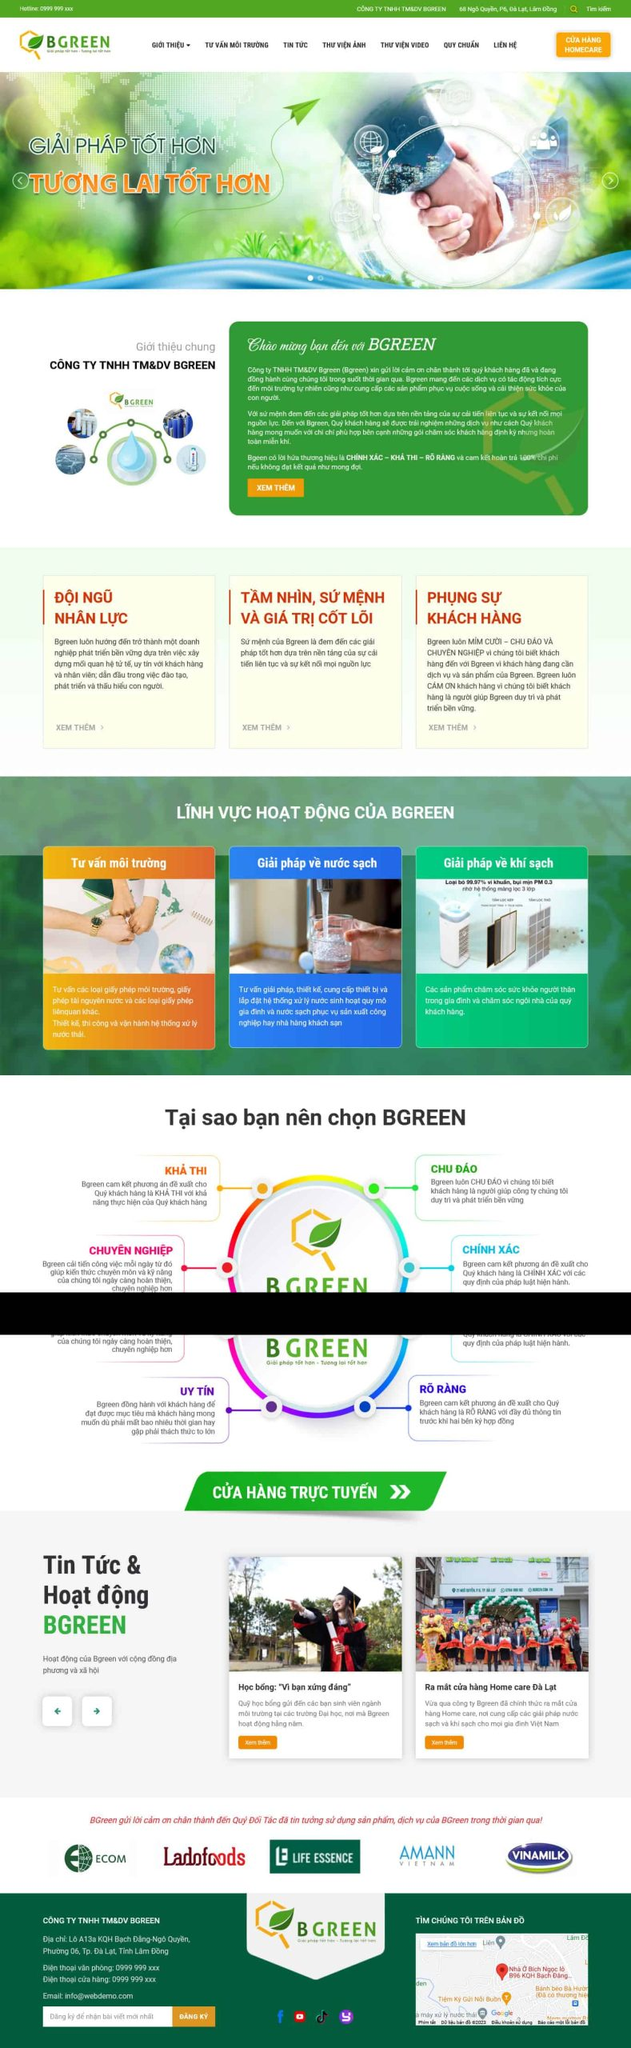Liệt kê 5 ngành nghề, lĩnh vực phù hợp với website này, phân cách các màu sắc bằng dấu phẩy. Chỉ trả về kết quả, phân cách bằng dấy phẩy
 Tư vấn môi trường, Giải pháp về nước sạch, Giải pháp về khí sạch, Đào tạo nhân lực, Dịch vụ khách hàng 